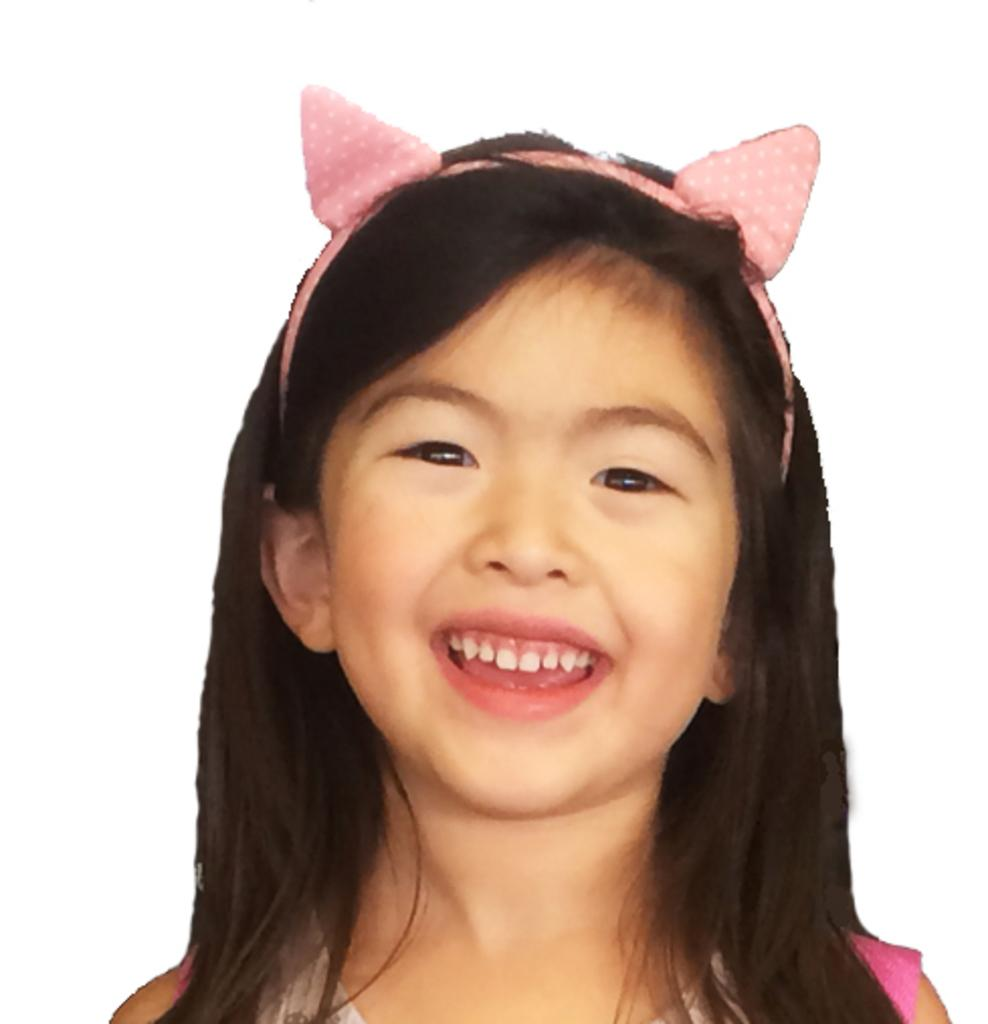Who is the main subject in the picture? There is a girl in the picture. What is the girl's expression in the image? The girl is smiling in the image. What is the girl wearing on her head? The girl is wearing head wear in the image. What color is the background of the image? The background of the image is white. Can you see any clouds in the image? There are no clouds visible in the image, as the background is white and the focus is on the girl. Is there a baby present in the image? There is no baby present in the image; the main subject is a girl. 